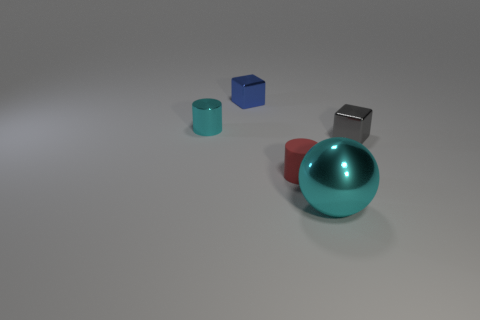There is a shiny object in front of the small red matte object; does it have the same color as the object that is behind the cyan cylinder?
Give a very brief answer. No. What number of other things are the same color as the matte cylinder?
Make the answer very short. 0. What number of red things are metallic cylinders or big metal spheres?
Your answer should be compact. 0. Do the big cyan thing and the cyan shiny object that is behind the big cyan metallic object have the same shape?
Your answer should be very brief. No. The large cyan object is what shape?
Ensure brevity in your answer.  Sphere. What material is the blue thing that is the same size as the red cylinder?
Ensure brevity in your answer.  Metal. Are there any other things that are the same size as the blue thing?
Ensure brevity in your answer.  Yes. What number of objects are small blocks or metal things that are behind the tiny cyan metal object?
Keep it short and to the point. 2. There is a gray block that is the same material as the small blue cube; what size is it?
Give a very brief answer. Small. There is a small thing that is right of the tiny cylinder that is on the right side of the tiny blue block; what shape is it?
Your answer should be compact. Cube. 